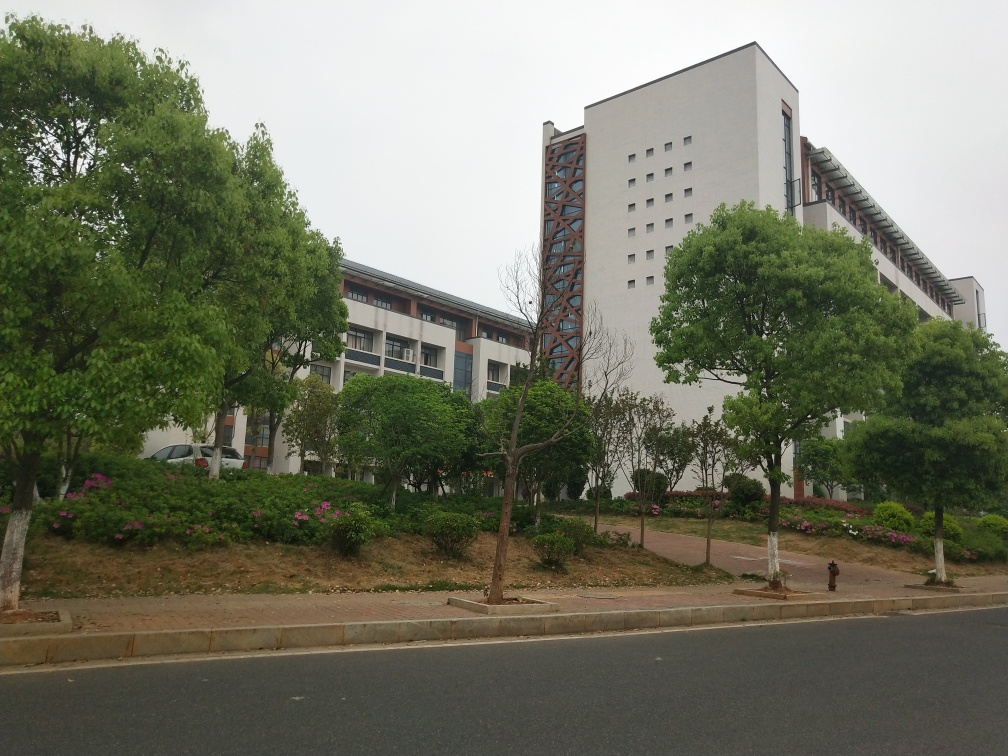Is there any blurriness in the image? Based on my analysis, there does not appear to be significant blurriness in the image. The silhouettes of buildings, trees, and the street are clear, suggesting that the photo is generally in focus. However, minor blurriness in photography can sometimes be subtle and not immediately evident at first glance, especially in areas with less contrast. 